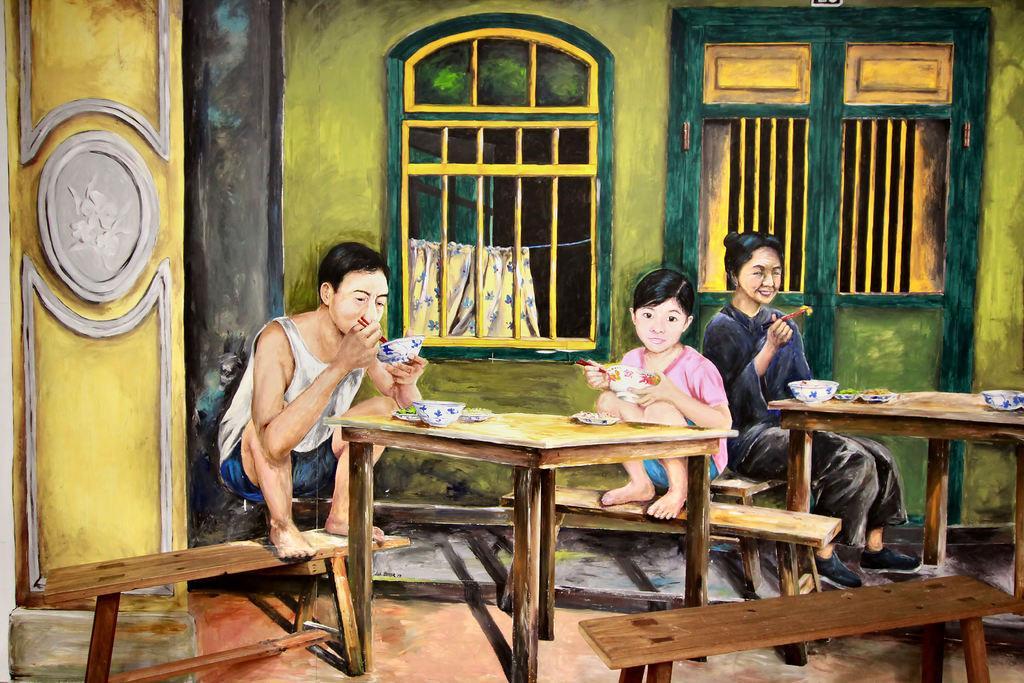How would you summarize this image in a sentence or two? In the picture we can see the painting of inside the house view with a man sitting near the table on the stool and he is holding a bowl with spoon and in front of him we can see the boy is also holding a spoon and behind him we can see a woman sitting on the bench and holding the bowl and in the background we can see windows. 